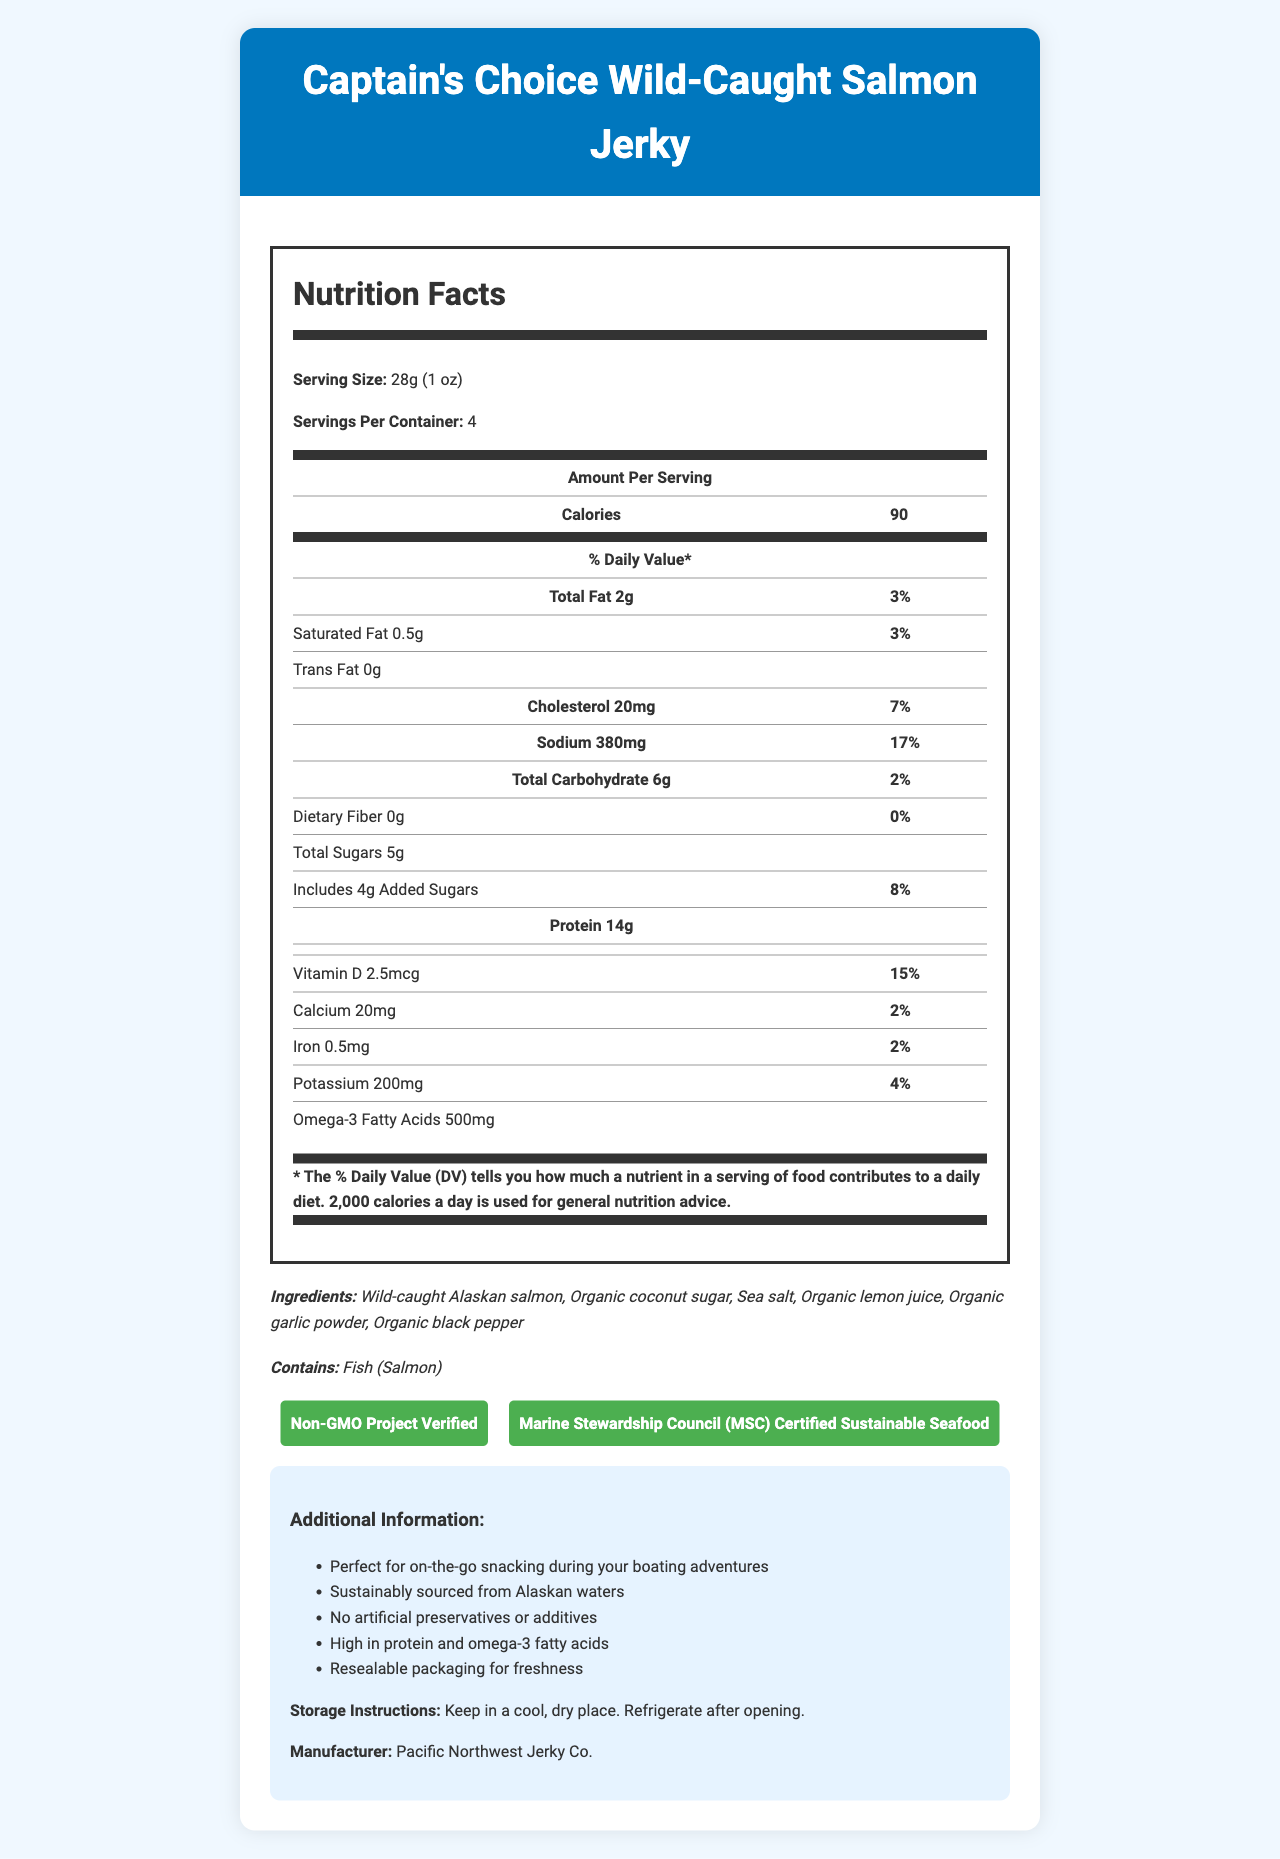what is the serving size for the Captain's Choice Wild-Caught Salmon Jerky? The serving size is listed under the "Serving Size" section in the Nutrition Facts.
Answer: 28g (1 oz) how many calories are in one serving? The document specifies that there are 90 calories per serving in the nutrition information table.
Answer: 90 what is the total fat content per serving? The total fat content is given as 2g in the Nutrition Facts.
Answer: 2g what is the sodium content per serving? The sodium content per serving is 380mg, detailed in the Nutrition Facts table.
Answer: 380mg how much protein is in each serving? The protein content per serving is noted as 14g in the Nutrition Facts table.
Answer: 14g which certifications does the product have? A. Non-GMO Project Verified B. Marine Stewardship Council (MSC) Certified C. USDA Organic D. Gluten-Free The certifications listed are Non-GMO Project Verified and Marine Stewardship Council (MSC) Certified.
Answer: A, B what are the first three ingredients listed? A. Sea salt, Organic lemon juice, Organic garlic powder B. Wild-caught Alaskan salmon, Organic coconut sugar, Sea salt C. Organic black pepper, Wild-caught Alaskan salmon, Sea salt The first three ingredients listed are Wild-caught Alaskan salmon, Organic coconut sugar, and Sea salt.
Answer: B does this product contain artificial preservatives or additives? The document states "No artificial preservatives or additives" in the additional information section.
Answer: No is the packaging resealable for freshness? The additional information section mentions that the packaging is resealable for freshness.
Answer: Yes describe the main idea of this document. The document includes a comprehensive breakdown of the nutritional values per serving, ingredients list, allergen information, certifications, storage instructions, manufacturer details, and additional benefits and features of the product.
Answer: The document provides detailed nutritional information, ingredients, allergens, certifications, storage instructions, and additional info for Captain's Choice Wild-Caught Salmon Jerky. who is the manufacturer of this product? The manufacturer is listed as Pacific Northwest Jerky Co. at the end of the additional information section.
Answer: Pacific Northwest Jerky Co. what is the daily value percentage of vitamin D in one serving? The daily value percentage for vitamin D per serving is given as 15% in the nutrition details.
Answer: 15% how much omega-3 fatty acids are in one serving? The document lists 500mg of omega-3 fatty acids per serving in the nutrition details.
Answer: 500mg what is the storage instruction for this product? The storage instructions mentioned are to keep the product in a cool, dry place and refrigerate after opening.
Answer: Keep in a cool, dry place. Refrigerate after opening. how many servings are there per container? The document states that there are 4 servings per container.
Answer: 4 is this product high in protein? The product contains 14g of protein per serving, which is considered high.
Answer: Yes what are the daily value percentages of calcium and iron per serving? Both calcium and iron have daily value percentages of 2% per serving as listed in the nutrition information.
Answer: 2%, 2% are there any dietary fibers in this product? The dietary fiber content is listed as 0g and 0% daily value.
Answer: No does this product contain any allergens? The allergen listed is Fish (Salmon), detailed in the allergens section.
Answer: Yes, Fish (Salmon) how many grams of carbohydrates are in one serving? The total carbohydrates per serving are listed as 6g in the Nutrition Facts.
Answer: 6g who is the target audience for this product? The document does not provide specific information about the target audience, only general information about the product's benefits.
Answer: Cannot be determined 